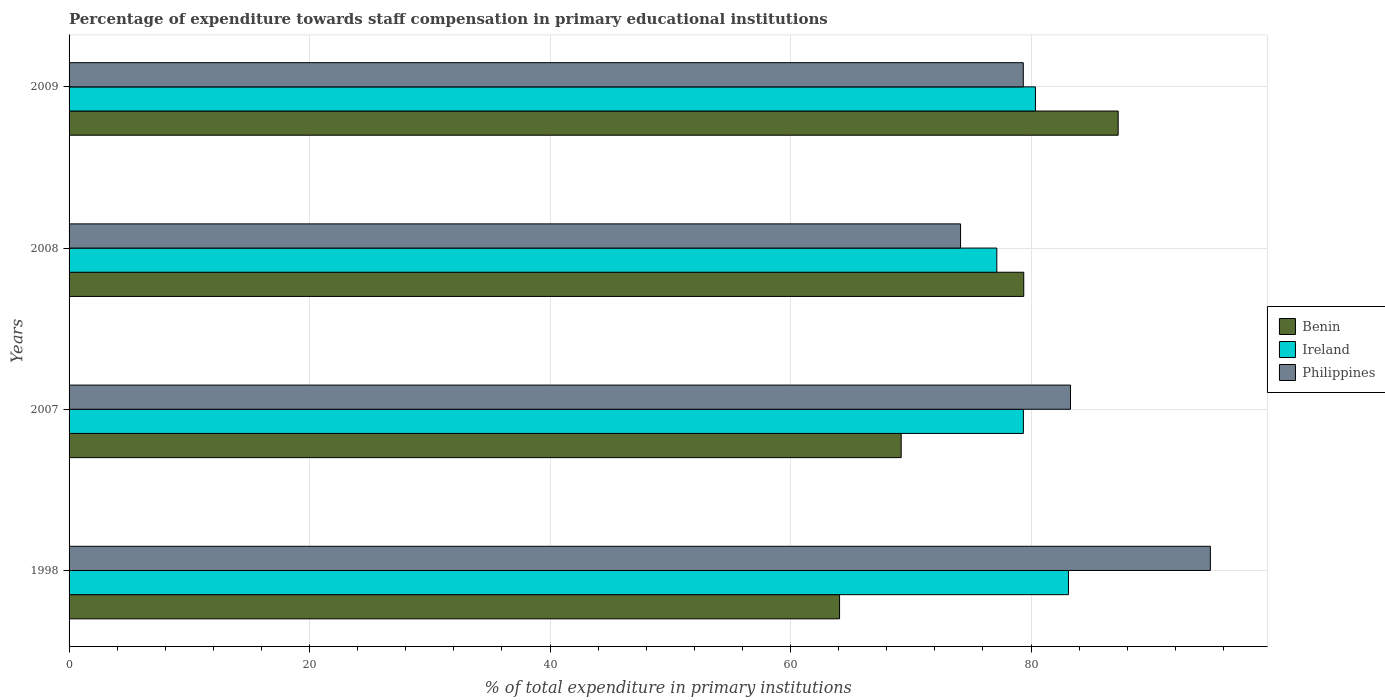Are the number of bars per tick equal to the number of legend labels?
Make the answer very short. Yes. Are the number of bars on each tick of the Y-axis equal?
Give a very brief answer. Yes. How many bars are there on the 1st tick from the top?
Your answer should be very brief. 3. What is the label of the 4th group of bars from the top?
Keep it short and to the point. 1998. In how many cases, is the number of bars for a given year not equal to the number of legend labels?
Keep it short and to the point. 0. What is the percentage of expenditure towards staff compensation in Ireland in 2008?
Provide a short and direct response. 77.15. Across all years, what is the maximum percentage of expenditure towards staff compensation in Philippines?
Offer a very short reply. 94.91. Across all years, what is the minimum percentage of expenditure towards staff compensation in Ireland?
Your answer should be compact. 77.15. In which year was the percentage of expenditure towards staff compensation in Ireland minimum?
Your response must be concise. 2008. What is the total percentage of expenditure towards staff compensation in Benin in the graph?
Ensure brevity in your answer.  299.92. What is the difference between the percentage of expenditure towards staff compensation in Philippines in 2007 and that in 2008?
Make the answer very short. 9.14. What is the difference between the percentage of expenditure towards staff compensation in Benin in 2009 and the percentage of expenditure towards staff compensation in Ireland in 2008?
Provide a succinct answer. 10.09. What is the average percentage of expenditure towards staff compensation in Benin per year?
Your answer should be very brief. 74.98. In the year 2008, what is the difference between the percentage of expenditure towards staff compensation in Philippines and percentage of expenditure towards staff compensation in Benin?
Ensure brevity in your answer.  -5.26. What is the ratio of the percentage of expenditure towards staff compensation in Philippines in 1998 to that in 2008?
Your response must be concise. 1.28. Is the percentage of expenditure towards staff compensation in Benin in 2007 less than that in 2008?
Ensure brevity in your answer.  Yes. What is the difference between the highest and the second highest percentage of expenditure towards staff compensation in Philippines?
Offer a very short reply. 11.63. What is the difference between the highest and the lowest percentage of expenditure towards staff compensation in Philippines?
Ensure brevity in your answer.  20.78. In how many years, is the percentage of expenditure towards staff compensation in Philippines greater than the average percentage of expenditure towards staff compensation in Philippines taken over all years?
Give a very brief answer. 2. What does the 3rd bar from the top in 2008 represents?
Offer a terse response. Benin. What does the 3rd bar from the bottom in 2008 represents?
Provide a short and direct response. Philippines. Is it the case that in every year, the sum of the percentage of expenditure towards staff compensation in Benin and percentage of expenditure towards staff compensation in Philippines is greater than the percentage of expenditure towards staff compensation in Ireland?
Your answer should be very brief. Yes. How many years are there in the graph?
Ensure brevity in your answer.  4. Does the graph contain any zero values?
Provide a short and direct response. No. Where does the legend appear in the graph?
Offer a very short reply. Center right. What is the title of the graph?
Offer a terse response. Percentage of expenditure towards staff compensation in primary educational institutions. Does "Tuvalu" appear as one of the legend labels in the graph?
Keep it short and to the point. No. What is the label or title of the X-axis?
Provide a short and direct response. % of total expenditure in primary institutions. What is the label or title of the Y-axis?
Your answer should be very brief. Years. What is the % of total expenditure in primary institutions in Benin in 1998?
Your answer should be compact. 64.08. What is the % of total expenditure in primary institutions in Ireland in 1998?
Give a very brief answer. 83.11. What is the % of total expenditure in primary institutions of Philippines in 1998?
Your answer should be very brief. 94.91. What is the % of total expenditure in primary institutions of Benin in 2007?
Give a very brief answer. 69.2. What is the % of total expenditure in primary institutions in Ireland in 2007?
Ensure brevity in your answer.  79.36. What is the % of total expenditure in primary institutions of Philippines in 2007?
Make the answer very short. 83.28. What is the % of total expenditure in primary institutions in Benin in 2008?
Offer a very short reply. 79.39. What is the % of total expenditure in primary institutions of Ireland in 2008?
Give a very brief answer. 77.15. What is the % of total expenditure in primary institutions of Philippines in 2008?
Give a very brief answer. 74.14. What is the % of total expenditure in primary institutions of Benin in 2009?
Your answer should be very brief. 87.25. What is the % of total expenditure in primary institutions in Ireland in 2009?
Your answer should be compact. 80.37. What is the % of total expenditure in primary institutions of Philippines in 2009?
Offer a terse response. 79.35. Across all years, what is the maximum % of total expenditure in primary institutions in Benin?
Make the answer very short. 87.25. Across all years, what is the maximum % of total expenditure in primary institutions of Ireland?
Offer a terse response. 83.11. Across all years, what is the maximum % of total expenditure in primary institutions in Philippines?
Your answer should be compact. 94.91. Across all years, what is the minimum % of total expenditure in primary institutions in Benin?
Offer a terse response. 64.08. Across all years, what is the minimum % of total expenditure in primary institutions of Ireland?
Give a very brief answer. 77.15. Across all years, what is the minimum % of total expenditure in primary institutions in Philippines?
Keep it short and to the point. 74.14. What is the total % of total expenditure in primary institutions of Benin in the graph?
Ensure brevity in your answer.  299.92. What is the total % of total expenditure in primary institutions of Ireland in the graph?
Your answer should be very brief. 320. What is the total % of total expenditure in primary institutions of Philippines in the graph?
Offer a terse response. 331.69. What is the difference between the % of total expenditure in primary institutions in Benin in 1998 and that in 2007?
Provide a short and direct response. -5.13. What is the difference between the % of total expenditure in primary institutions in Ireland in 1998 and that in 2007?
Offer a terse response. 3.75. What is the difference between the % of total expenditure in primary institutions in Philippines in 1998 and that in 2007?
Your response must be concise. 11.63. What is the difference between the % of total expenditure in primary institutions of Benin in 1998 and that in 2008?
Your answer should be very brief. -15.32. What is the difference between the % of total expenditure in primary institutions in Ireland in 1998 and that in 2008?
Provide a short and direct response. 5.96. What is the difference between the % of total expenditure in primary institutions of Philippines in 1998 and that in 2008?
Provide a short and direct response. 20.78. What is the difference between the % of total expenditure in primary institutions of Benin in 1998 and that in 2009?
Provide a short and direct response. -23.17. What is the difference between the % of total expenditure in primary institutions of Ireland in 1998 and that in 2009?
Offer a very short reply. 2.75. What is the difference between the % of total expenditure in primary institutions of Philippines in 1998 and that in 2009?
Your response must be concise. 15.56. What is the difference between the % of total expenditure in primary institutions in Benin in 2007 and that in 2008?
Your response must be concise. -10.19. What is the difference between the % of total expenditure in primary institutions in Ireland in 2007 and that in 2008?
Provide a succinct answer. 2.21. What is the difference between the % of total expenditure in primary institutions in Philippines in 2007 and that in 2008?
Keep it short and to the point. 9.14. What is the difference between the % of total expenditure in primary institutions in Benin in 2007 and that in 2009?
Your response must be concise. -18.05. What is the difference between the % of total expenditure in primary institutions of Ireland in 2007 and that in 2009?
Ensure brevity in your answer.  -1. What is the difference between the % of total expenditure in primary institutions of Philippines in 2007 and that in 2009?
Your answer should be very brief. 3.93. What is the difference between the % of total expenditure in primary institutions in Benin in 2008 and that in 2009?
Provide a succinct answer. -7.85. What is the difference between the % of total expenditure in primary institutions in Ireland in 2008 and that in 2009?
Provide a short and direct response. -3.21. What is the difference between the % of total expenditure in primary institutions in Philippines in 2008 and that in 2009?
Ensure brevity in your answer.  -5.22. What is the difference between the % of total expenditure in primary institutions in Benin in 1998 and the % of total expenditure in primary institutions in Ireland in 2007?
Your answer should be compact. -15.29. What is the difference between the % of total expenditure in primary institutions of Benin in 1998 and the % of total expenditure in primary institutions of Philippines in 2007?
Your answer should be very brief. -19.21. What is the difference between the % of total expenditure in primary institutions in Ireland in 1998 and the % of total expenditure in primary institutions in Philippines in 2007?
Provide a short and direct response. -0.17. What is the difference between the % of total expenditure in primary institutions in Benin in 1998 and the % of total expenditure in primary institutions in Ireland in 2008?
Your answer should be compact. -13.08. What is the difference between the % of total expenditure in primary institutions of Benin in 1998 and the % of total expenditure in primary institutions of Philippines in 2008?
Keep it short and to the point. -10.06. What is the difference between the % of total expenditure in primary institutions in Ireland in 1998 and the % of total expenditure in primary institutions in Philippines in 2008?
Make the answer very short. 8.98. What is the difference between the % of total expenditure in primary institutions of Benin in 1998 and the % of total expenditure in primary institutions of Ireland in 2009?
Offer a very short reply. -16.29. What is the difference between the % of total expenditure in primary institutions in Benin in 1998 and the % of total expenditure in primary institutions in Philippines in 2009?
Your answer should be compact. -15.28. What is the difference between the % of total expenditure in primary institutions in Ireland in 1998 and the % of total expenditure in primary institutions in Philippines in 2009?
Offer a very short reply. 3.76. What is the difference between the % of total expenditure in primary institutions in Benin in 2007 and the % of total expenditure in primary institutions in Ireland in 2008?
Ensure brevity in your answer.  -7.95. What is the difference between the % of total expenditure in primary institutions in Benin in 2007 and the % of total expenditure in primary institutions in Philippines in 2008?
Make the answer very short. -4.94. What is the difference between the % of total expenditure in primary institutions of Ireland in 2007 and the % of total expenditure in primary institutions of Philippines in 2008?
Provide a short and direct response. 5.23. What is the difference between the % of total expenditure in primary institutions of Benin in 2007 and the % of total expenditure in primary institutions of Ireland in 2009?
Make the answer very short. -11.17. What is the difference between the % of total expenditure in primary institutions in Benin in 2007 and the % of total expenditure in primary institutions in Philippines in 2009?
Your answer should be compact. -10.15. What is the difference between the % of total expenditure in primary institutions of Ireland in 2007 and the % of total expenditure in primary institutions of Philippines in 2009?
Your answer should be very brief. 0.01. What is the difference between the % of total expenditure in primary institutions of Benin in 2008 and the % of total expenditure in primary institutions of Ireland in 2009?
Give a very brief answer. -0.97. What is the difference between the % of total expenditure in primary institutions in Benin in 2008 and the % of total expenditure in primary institutions in Philippines in 2009?
Keep it short and to the point. 0.04. What is the difference between the % of total expenditure in primary institutions in Ireland in 2008 and the % of total expenditure in primary institutions in Philippines in 2009?
Keep it short and to the point. -2.2. What is the average % of total expenditure in primary institutions of Benin per year?
Your response must be concise. 74.98. What is the average % of total expenditure in primary institutions of Ireland per year?
Offer a terse response. 80. What is the average % of total expenditure in primary institutions in Philippines per year?
Provide a short and direct response. 82.92. In the year 1998, what is the difference between the % of total expenditure in primary institutions in Benin and % of total expenditure in primary institutions in Ireland?
Provide a succinct answer. -19.04. In the year 1998, what is the difference between the % of total expenditure in primary institutions in Benin and % of total expenditure in primary institutions in Philippines?
Keep it short and to the point. -30.84. In the year 1998, what is the difference between the % of total expenditure in primary institutions in Ireland and % of total expenditure in primary institutions in Philippines?
Ensure brevity in your answer.  -11.8. In the year 2007, what is the difference between the % of total expenditure in primary institutions of Benin and % of total expenditure in primary institutions of Ireland?
Provide a succinct answer. -10.16. In the year 2007, what is the difference between the % of total expenditure in primary institutions of Benin and % of total expenditure in primary institutions of Philippines?
Your response must be concise. -14.08. In the year 2007, what is the difference between the % of total expenditure in primary institutions in Ireland and % of total expenditure in primary institutions in Philippines?
Keep it short and to the point. -3.92. In the year 2008, what is the difference between the % of total expenditure in primary institutions in Benin and % of total expenditure in primary institutions in Ireland?
Your answer should be compact. 2.24. In the year 2008, what is the difference between the % of total expenditure in primary institutions of Benin and % of total expenditure in primary institutions of Philippines?
Provide a succinct answer. 5.26. In the year 2008, what is the difference between the % of total expenditure in primary institutions of Ireland and % of total expenditure in primary institutions of Philippines?
Your answer should be very brief. 3.02. In the year 2009, what is the difference between the % of total expenditure in primary institutions in Benin and % of total expenditure in primary institutions in Ireland?
Your answer should be very brief. 6.88. In the year 2009, what is the difference between the % of total expenditure in primary institutions in Benin and % of total expenditure in primary institutions in Philippines?
Ensure brevity in your answer.  7.89. In the year 2009, what is the difference between the % of total expenditure in primary institutions of Ireland and % of total expenditure in primary institutions of Philippines?
Offer a terse response. 1.01. What is the ratio of the % of total expenditure in primary institutions in Benin in 1998 to that in 2007?
Ensure brevity in your answer.  0.93. What is the ratio of the % of total expenditure in primary institutions in Ireland in 1998 to that in 2007?
Offer a very short reply. 1.05. What is the ratio of the % of total expenditure in primary institutions of Philippines in 1998 to that in 2007?
Your answer should be compact. 1.14. What is the ratio of the % of total expenditure in primary institutions of Benin in 1998 to that in 2008?
Your answer should be very brief. 0.81. What is the ratio of the % of total expenditure in primary institutions of Ireland in 1998 to that in 2008?
Offer a terse response. 1.08. What is the ratio of the % of total expenditure in primary institutions of Philippines in 1998 to that in 2008?
Offer a very short reply. 1.28. What is the ratio of the % of total expenditure in primary institutions of Benin in 1998 to that in 2009?
Provide a succinct answer. 0.73. What is the ratio of the % of total expenditure in primary institutions in Ireland in 1998 to that in 2009?
Your answer should be very brief. 1.03. What is the ratio of the % of total expenditure in primary institutions of Philippines in 1998 to that in 2009?
Keep it short and to the point. 1.2. What is the ratio of the % of total expenditure in primary institutions in Benin in 2007 to that in 2008?
Offer a very short reply. 0.87. What is the ratio of the % of total expenditure in primary institutions in Ireland in 2007 to that in 2008?
Give a very brief answer. 1.03. What is the ratio of the % of total expenditure in primary institutions in Philippines in 2007 to that in 2008?
Provide a short and direct response. 1.12. What is the ratio of the % of total expenditure in primary institutions in Benin in 2007 to that in 2009?
Keep it short and to the point. 0.79. What is the ratio of the % of total expenditure in primary institutions of Ireland in 2007 to that in 2009?
Provide a short and direct response. 0.99. What is the ratio of the % of total expenditure in primary institutions in Philippines in 2007 to that in 2009?
Make the answer very short. 1.05. What is the ratio of the % of total expenditure in primary institutions in Benin in 2008 to that in 2009?
Provide a succinct answer. 0.91. What is the ratio of the % of total expenditure in primary institutions of Philippines in 2008 to that in 2009?
Your answer should be very brief. 0.93. What is the difference between the highest and the second highest % of total expenditure in primary institutions in Benin?
Your answer should be very brief. 7.85. What is the difference between the highest and the second highest % of total expenditure in primary institutions of Ireland?
Your answer should be very brief. 2.75. What is the difference between the highest and the second highest % of total expenditure in primary institutions in Philippines?
Provide a succinct answer. 11.63. What is the difference between the highest and the lowest % of total expenditure in primary institutions of Benin?
Your response must be concise. 23.17. What is the difference between the highest and the lowest % of total expenditure in primary institutions of Ireland?
Offer a very short reply. 5.96. What is the difference between the highest and the lowest % of total expenditure in primary institutions of Philippines?
Offer a very short reply. 20.78. 